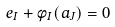Convert formula to latex. <formula><loc_0><loc_0><loc_500><loc_500>e _ { I } + \phi _ { I } ( a _ { J } ) = 0</formula> 